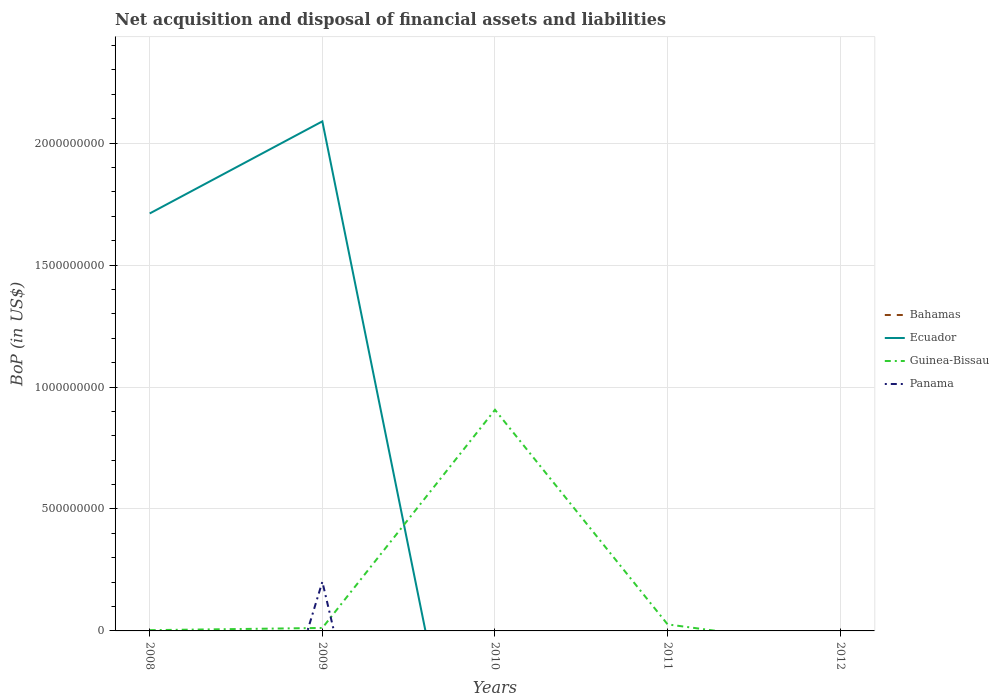How many different coloured lines are there?
Your response must be concise. 3. What is the total Balance of Payments in Guinea-Bissau in the graph?
Ensure brevity in your answer.  -9.03e+08. What is the difference between the highest and the second highest Balance of Payments in Guinea-Bissau?
Your answer should be very brief. 9.07e+08. Is the Balance of Payments in Guinea-Bissau strictly greater than the Balance of Payments in Panama over the years?
Make the answer very short. No. How many lines are there?
Your answer should be very brief. 3. How many years are there in the graph?
Your response must be concise. 5. Are the values on the major ticks of Y-axis written in scientific E-notation?
Offer a very short reply. No. Does the graph contain grids?
Give a very brief answer. Yes. How many legend labels are there?
Provide a succinct answer. 4. What is the title of the graph?
Keep it short and to the point. Net acquisition and disposal of financial assets and liabilities. Does "Marshall Islands" appear as one of the legend labels in the graph?
Ensure brevity in your answer.  No. What is the label or title of the Y-axis?
Give a very brief answer. BoP (in US$). What is the BoP (in US$) of Bahamas in 2008?
Your response must be concise. 0. What is the BoP (in US$) in Ecuador in 2008?
Make the answer very short. 1.71e+09. What is the BoP (in US$) in Guinea-Bissau in 2008?
Your answer should be very brief. 3.15e+06. What is the BoP (in US$) in Bahamas in 2009?
Provide a succinct answer. 0. What is the BoP (in US$) of Ecuador in 2009?
Offer a very short reply. 2.09e+09. What is the BoP (in US$) of Guinea-Bissau in 2009?
Make the answer very short. 1.22e+07. What is the BoP (in US$) in Panama in 2009?
Offer a terse response. 2.02e+08. What is the BoP (in US$) in Ecuador in 2010?
Your answer should be compact. 0. What is the BoP (in US$) of Guinea-Bissau in 2010?
Offer a very short reply. 9.07e+08. What is the BoP (in US$) of Bahamas in 2011?
Make the answer very short. 0. What is the BoP (in US$) of Guinea-Bissau in 2011?
Provide a short and direct response. 2.67e+07. What is the BoP (in US$) in Guinea-Bissau in 2012?
Offer a very short reply. 0. Across all years, what is the maximum BoP (in US$) in Ecuador?
Give a very brief answer. 2.09e+09. Across all years, what is the maximum BoP (in US$) in Guinea-Bissau?
Provide a succinct answer. 9.07e+08. Across all years, what is the maximum BoP (in US$) in Panama?
Your response must be concise. 2.02e+08. Across all years, what is the minimum BoP (in US$) of Ecuador?
Offer a very short reply. 0. Across all years, what is the minimum BoP (in US$) in Guinea-Bissau?
Offer a very short reply. 0. Across all years, what is the minimum BoP (in US$) of Panama?
Offer a terse response. 0. What is the total BoP (in US$) of Bahamas in the graph?
Make the answer very short. 0. What is the total BoP (in US$) in Ecuador in the graph?
Your response must be concise. 3.80e+09. What is the total BoP (in US$) of Guinea-Bissau in the graph?
Ensure brevity in your answer.  9.49e+08. What is the total BoP (in US$) in Panama in the graph?
Provide a succinct answer. 2.02e+08. What is the difference between the BoP (in US$) in Ecuador in 2008 and that in 2009?
Ensure brevity in your answer.  -3.78e+08. What is the difference between the BoP (in US$) of Guinea-Bissau in 2008 and that in 2009?
Ensure brevity in your answer.  -9.01e+06. What is the difference between the BoP (in US$) of Guinea-Bissau in 2008 and that in 2010?
Offer a very short reply. -9.03e+08. What is the difference between the BoP (in US$) of Guinea-Bissau in 2008 and that in 2011?
Offer a very short reply. -2.36e+07. What is the difference between the BoP (in US$) in Guinea-Bissau in 2009 and that in 2010?
Make the answer very short. -8.94e+08. What is the difference between the BoP (in US$) in Guinea-Bissau in 2009 and that in 2011?
Give a very brief answer. -1.46e+07. What is the difference between the BoP (in US$) in Guinea-Bissau in 2010 and that in 2011?
Ensure brevity in your answer.  8.80e+08. What is the difference between the BoP (in US$) in Ecuador in 2008 and the BoP (in US$) in Guinea-Bissau in 2009?
Offer a very short reply. 1.70e+09. What is the difference between the BoP (in US$) in Ecuador in 2008 and the BoP (in US$) in Panama in 2009?
Your response must be concise. 1.51e+09. What is the difference between the BoP (in US$) of Guinea-Bissau in 2008 and the BoP (in US$) of Panama in 2009?
Give a very brief answer. -1.98e+08. What is the difference between the BoP (in US$) in Ecuador in 2008 and the BoP (in US$) in Guinea-Bissau in 2010?
Your answer should be very brief. 8.05e+08. What is the difference between the BoP (in US$) in Ecuador in 2008 and the BoP (in US$) in Guinea-Bissau in 2011?
Your answer should be compact. 1.68e+09. What is the difference between the BoP (in US$) in Ecuador in 2009 and the BoP (in US$) in Guinea-Bissau in 2010?
Your response must be concise. 1.18e+09. What is the difference between the BoP (in US$) of Ecuador in 2009 and the BoP (in US$) of Guinea-Bissau in 2011?
Your response must be concise. 2.06e+09. What is the average BoP (in US$) of Ecuador per year?
Keep it short and to the point. 7.60e+08. What is the average BoP (in US$) in Guinea-Bissau per year?
Your response must be concise. 1.90e+08. What is the average BoP (in US$) of Panama per year?
Your answer should be very brief. 4.03e+07. In the year 2008, what is the difference between the BoP (in US$) of Ecuador and BoP (in US$) of Guinea-Bissau?
Offer a terse response. 1.71e+09. In the year 2009, what is the difference between the BoP (in US$) in Ecuador and BoP (in US$) in Guinea-Bissau?
Provide a short and direct response. 2.08e+09. In the year 2009, what is the difference between the BoP (in US$) in Ecuador and BoP (in US$) in Panama?
Make the answer very short. 1.89e+09. In the year 2009, what is the difference between the BoP (in US$) of Guinea-Bissau and BoP (in US$) of Panama?
Ensure brevity in your answer.  -1.89e+08. What is the ratio of the BoP (in US$) in Ecuador in 2008 to that in 2009?
Offer a very short reply. 0.82. What is the ratio of the BoP (in US$) of Guinea-Bissau in 2008 to that in 2009?
Make the answer very short. 0.26. What is the ratio of the BoP (in US$) of Guinea-Bissau in 2008 to that in 2010?
Your answer should be very brief. 0. What is the ratio of the BoP (in US$) in Guinea-Bissau in 2008 to that in 2011?
Make the answer very short. 0.12. What is the ratio of the BoP (in US$) of Guinea-Bissau in 2009 to that in 2010?
Make the answer very short. 0.01. What is the ratio of the BoP (in US$) of Guinea-Bissau in 2009 to that in 2011?
Your answer should be very brief. 0.46. What is the ratio of the BoP (in US$) of Guinea-Bissau in 2010 to that in 2011?
Provide a succinct answer. 33.93. What is the difference between the highest and the second highest BoP (in US$) in Guinea-Bissau?
Ensure brevity in your answer.  8.80e+08. What is the difference between the highest and the lowest BoP (in US$) of Ecuador?
Provide a short and direct response. 2.09e+09. What is the difference between the highest and the lowest BoP (in US$) of Guinea-Bissau?
Your answer should be very brief. 9.07e+08. What is the difference between the highest and the lowest BoP (in US$) of Panama?
Your response must be concise. 2.02e+08. 